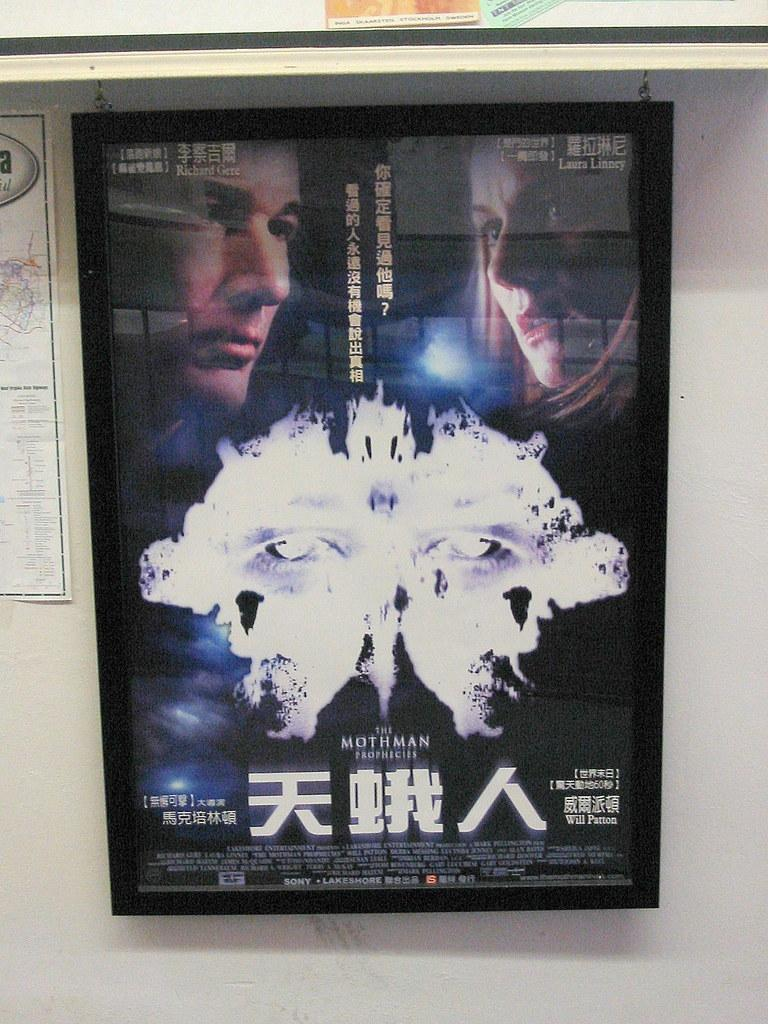<image>
Relay a brief, clear account of the picture shown. A movie in Chinese called The Mothman Prophecies 